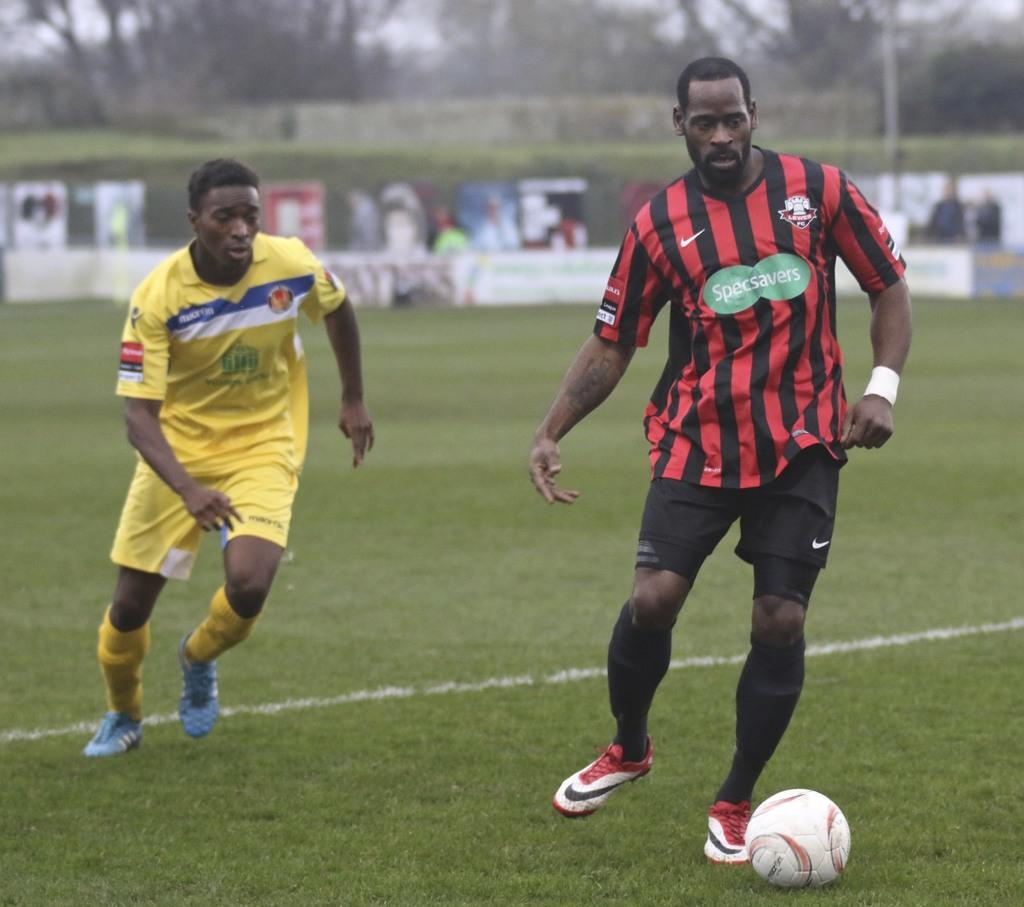Provide a one-sentence caption for the provided image. A soccer player for SpecSavers is dribbling the ball. 